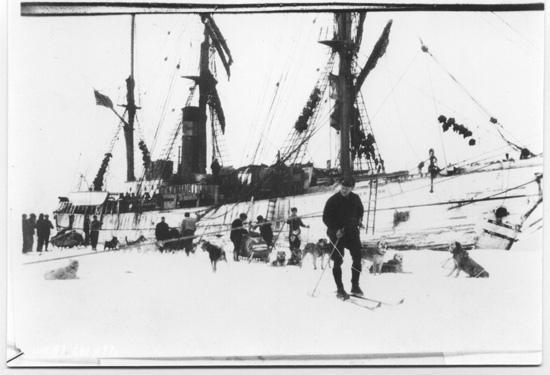How many yellow banana do you see in the picture?
Give a very brief answer. 0. 